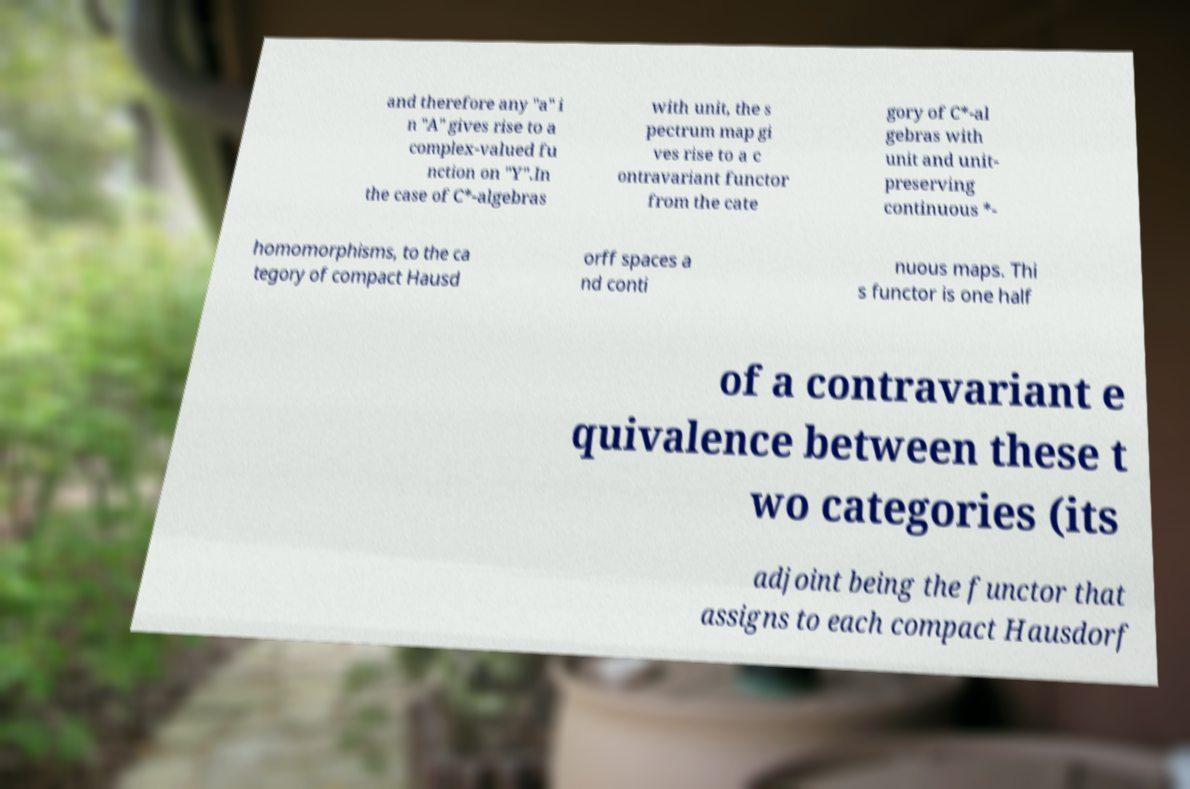What messages or text are displayed in this image? I need them in a readable, typed format. and therefore any "a" i n "A" gives rise to a complex-valued fu nction on "Y".In the case of C*-algebras with unit, the s pectrum map gi ves rise to a c ontravariant functor from the cate gory of C*-al gebras with unit and unit- preserving continuous *- homomorphisms, to the ca tegory of compact Hausd orff spaces a nd conti nuous maps. Thi s functor is one half of a contravariant e quivalence between these t wo categories (its adjoint being the functor that assigns to each compact Hausdorf 